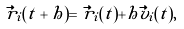Convert formula to latex. <formula><loc_0><loc_0><loc_500><loc_500>\vec { r } _ { i } ( t + h ) = \vec { r } _ { i } ( t ) + h \vec { v } _ { i } ( t ) ,</formula> 